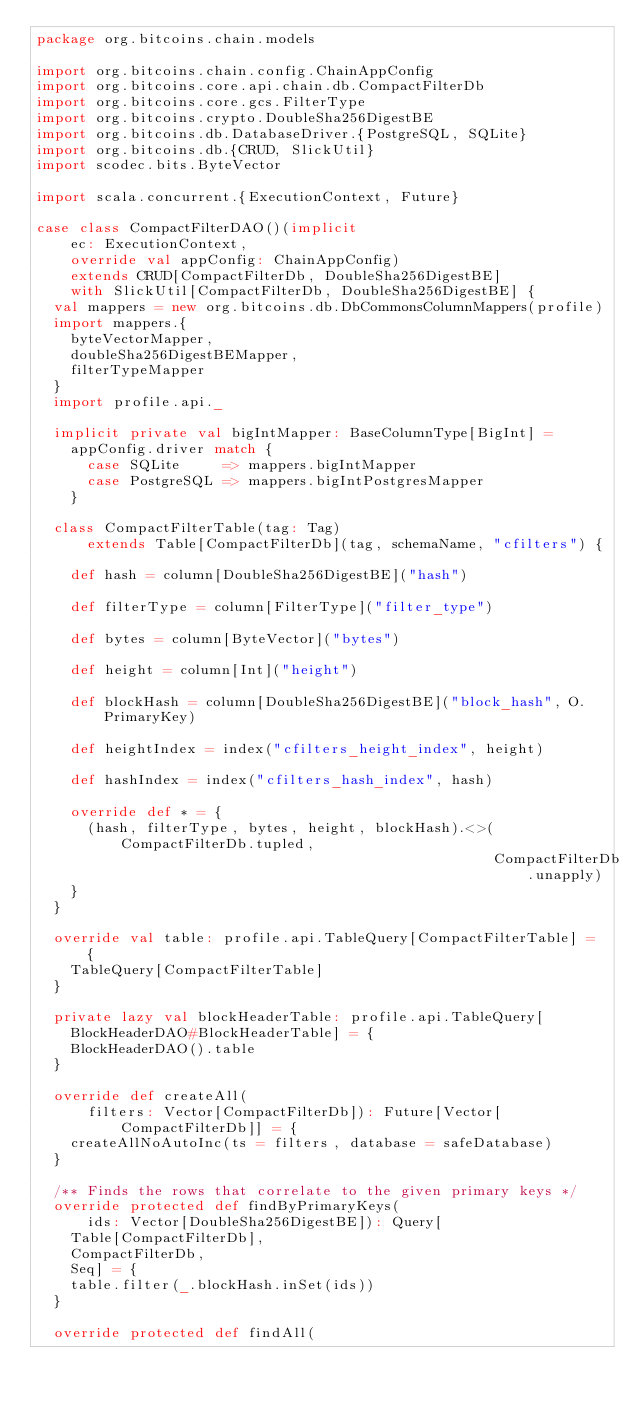Convert code to text. <code><loc_0><loc_0><loc_500><loc_500><_Scala_>package org.bitcoins.chain.models

import org.bitcoins.chain.config.ChainAppConfig
import org.bitcoins.core.api.chain.db.CompactFilterDb
import org.bitcoins.core.gcs.FilterType
import org.bitcoins.crypto.DoubleSha256DigestBE
import org.bitcoins.db.DatabaseDriver.{PostgreSQL, SQLite}
import org.bitcoins.db.{CRUD, SlickUtil}
import scodec.bits.ByteVector

import scala.concurrent.{ExecutionContext, Future}

case class CompactFilterDAO()(implicit
    ec: ExecutionContext,
    override val appConfig: ChainAppConfig)
    extends CRUD[CompactFilterDb, DoubleSha256DigestBE]
    with SlickUtil[CompactFilterDb, DoubleSha256DigestBE] {
  val mappers = new org.bitcoins.db.DbCommonsColumnMappers(profile)
  import mappers.{
    byteVectorMapper,
    doubleSha256DigestBEMapper,
    filterTypeMapper
  }
  import profile.api._

  implicit private val bigIntMapper: BaseColumnType[BigInt] =
    appConfig.driver match {
      case SQLite     => mappers.bigIntMapper
      case PostgreSQL => mappers.bigIntPostgresMapper
    }

  class CompactFilterTable(tag: Tag)
      extends Table[CompactFilterDb](tag, schemaName, "cfilters") {

    def hash = column[DoubleSha256DigestBE]("hash")

    def filterType = column[FilterType]("filter_type")

    def bytes = column[ByteVector]("bytes")

    def height = column[Int]("height")

    def blockHash = column[DoubleSha256DigestBE]("block_hash", O.PrimaryKey)

    def heightIndex = index("cfilters_height_index", height)

    def hashIndex = index("cfilters_hash_index", hash)

    override def * = {
      (hash, filterType, bytes, height, blockHash).<>(CompactFilterDb.tupled,
                                                      CompactFilterDb.unapply)
    }
  }

  override val table: profile.api.TableQuery[CompactFilterTable] = {
    TableQuery[CompactFilterTable]
  }

  private lazy val blockHeaderTable: profile.api.TableQuery[
    BlockHeaderDAO#BlockHeaderTable] = {
    BlockHeaderDAO().table
  }

  override def createAll(
      filters: Vector[CompactFilterDb]): Future[Vector[CompactFilterDb]] = {
    createAllNoAutoInc(ts = filters, database = safeDatabase)
  }

  /** Finds the rows that correlate to the given primary keys */
  override protected def findByPrimaryKeys(
      ids: Vector[DoubleSha256DigestBE]): Query[
    Table[CompactFilterDb],
    CompactFilterDb,
    Seq] = {
    table.filter(_.blockHash.inSet(ids))
  }

  override protected def findAll(</code> 